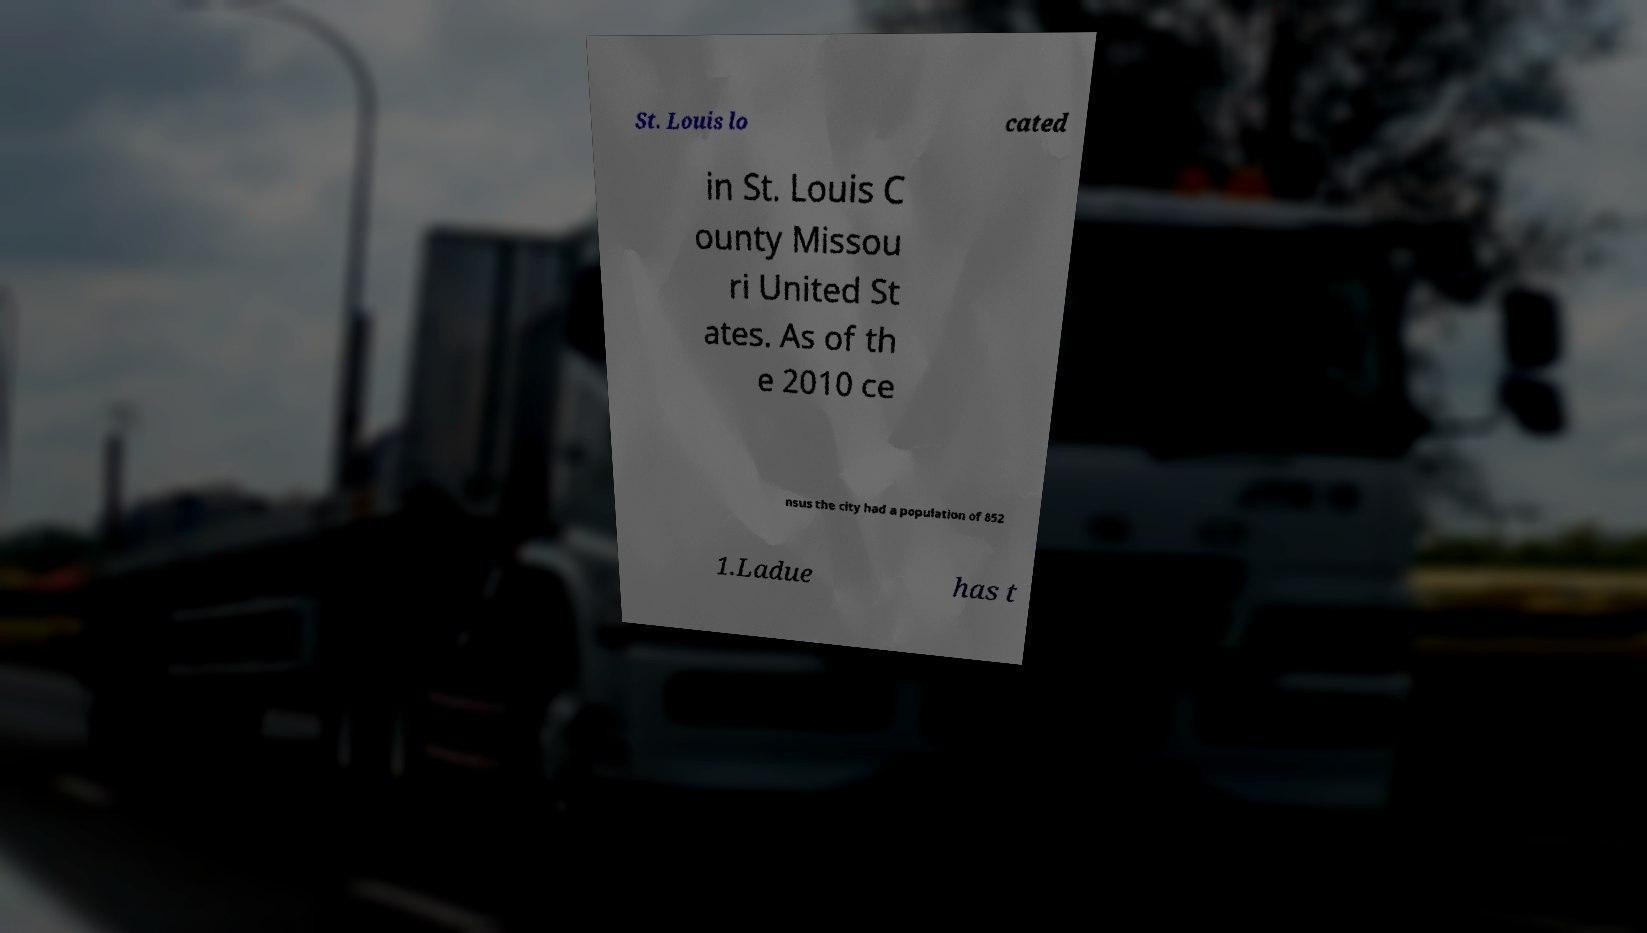Can you read and provide the text displayed in the image?This photo seems to have some interesting text. Can you extract and type it out for me? St. Louis lo cated in St. Louis C ounty Missou ri United St ates. As of th e 2010 ce nsus the city had a population of 852 1.Ladue has t 